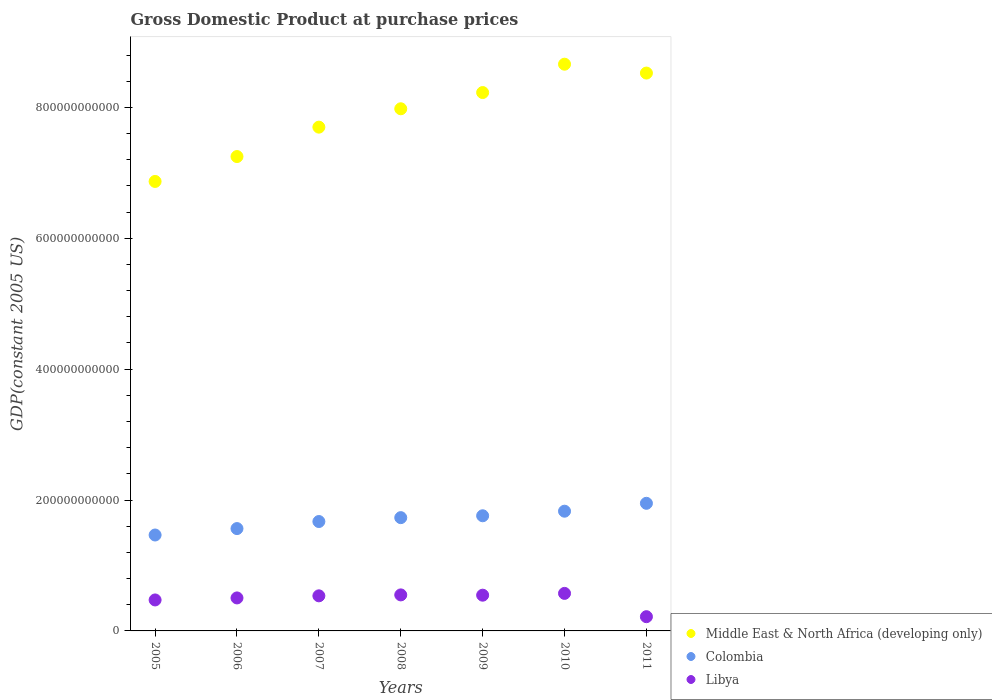How many different coloured dotlines are there?
Your response must be concise. 3. What is the GDP at purchase prices in Libya in 2009?
Offer a terse response. 5.46e+1. Across all years, what is the maximum GDP at purchase prices in Libya?
Give a very brief answer. 5.74e+1. Across all years, what is the minimum GDP at purchase prices in Colombia?
Provide a short and direct response. 1.47e+11. In which year was the GDP at purchase prices in Colombia maximum?
Give a very brief answer. 2011. In which year was the GDP at purchase prices in Libya minimum?
Make the answer very short. 2011. What is the total GDP at purchase prices in Libya in the graph?
Provide a succinct answer. 3.40e+11. What is the difference between the GDP at purchase prices in Libya in 2008 and that in 2011?
Your response must be concise. 3.33e+1. What is the difference between the GDP at purchase prices in Middle East & North Africa (developing only) in 2010 and the GDP at purchase prices in Colombia in 2009?
Your answer should be compact. 6.90e+11. What is the average GDP at purchase prices in Colombia per year?
Offer a terse response. 1.71e+11. In the year 2011, what is the difference between the GDP at purchase prices in Colombia and GDP at purchase prices in Libya?
Make the answer very short. 1.73e+11. In how many years, is the GDP at purchase prices in Middle East & North Africa (developing only) greater than 280000000000 US$?
Offer a terse response. 7. What is the ratio of the GDP at purchase prices in Middle East & North Africa (developing only) in 2005 to that in 2006?
Provide a succinct answer. 0.95. Is the GDP at purchase prices in Libya in 2005 less than that in 2009?
Keep it short and to the point. Yes. What is the difference between the highest and the second highest GDP at purchase prices in Libya?
Your response must be concise. 2.31e+09. What is the difference between the highest and the lowest GDP at purchase prices in Libya?
Offer a terse response. 3.56e+1. In how many years, is the GDP at purchase prices in Colombia greater than the average GDP at purchase prices in Colombia taken over all years?
Provide a short and direct response. 4. Is it the case that in every year, the sum of the GDP at purchase prices in Colombia and GDP at purchase prices in Middle East & North Africa (developing only)  is greater than the GDP at purchase prices in Libya?
Your response must be concise. Yes. How many dotlines are there?
Make the answer very short. 3. How many years are there in the graph?
Make the answer very short. 7. What is the difference between two consecutive major ticks on the Y-axis?
Your response must be concise. 2.00e+11. Are the values on the major ticks of Y-axis written in scientific E-notation?
Keep it short and to the point. No. How many legend labels are there?
Your answer should be very brief. 3. How are the legend labels stacked?
Keep it short and to the point. Vertical. What is the title of the graph?
Make the answer very short. Gross Domestic Product at purchase prices. What is the label or title of the Y-axis?
Provide a succinct answer. GDP(constant 2005 US). What is the GDP(constant 2005 US) in Middle East & North Africa (developing only) in 2005?
Ensure brevity in your answer.  6.87e+11. What is the GDP(constant 2005 US) of Colombia in 2005?
Your answer should be compact. 1.47e+11. What is the GDP(constant 2005 US) in Libya in 2005?
Your answer should be compact. 4.73e+1. What is the GDP(constant 2005 US) of Middle East & North Africa (developing only) in 2006?
Your answer should be compact. 7.25e+11. What is the GDP(constant 2005 US) of Colombia in 2006?
Ensure brevity in your answer.  1.56e+11. What is the GDP(constant 2005 US) in Libya in 2006?
Provide a short and direct response. 5.04e+1. What is the GDP(constant 2005 US) of Middle East & North Africa (developing only) in 2007?
Provide a succinct answer. 7.70e+11. What is the GDP(constant 2005 US) of Colombia in 2007?
Provide a short and direct response. 1.67e+11. What is the GDP(constant 2005 US) of Libya in 2007?
Ensure brevity in your answer.  5.36e+1. What is the GDP(constant 2005 US) of Middle East & North Africa (developing only) in 2008?
Your answer should be compact. 7.98e+11. What is the GDP(constant 2005 US) of Colombia in 2008?
Your response must be concise. 1.73e+11. What is the GDP(constant 2005 US) of Libya in 2008?
Offer a very short reply. 5.50e+1. What is the GDP(constant 2005 US) in Middle East & North Africa (developing only) in 2009?
Ensure brevity in your answer.  8.23e+11. What is the GDP(constant 2005 US) of Colombia in 2009?
Give a very brief answer. 1.76e+11. What is the GDP(constant 2005 US) in Libya in 2009?
Provide a succinct answer. 5.46e+1. What is the GDP(constant 2005 US) in Middle East & North Africa (developing only) in 2010?
Make the answer very short. 8.66e+11. What is the GDP(constant 2005 US) of Colombia in 2010?
Offer a very short reply. 1.83e+11. What is the GDP(constant 2005 US) of Libya in 2010?
Your answer should be compact. 5.74e+1. What is the GDP(constant 2005 US) of Middle East & North Africa (developing only) in 2011?
Your answer should be very brief. 8.52e+11. What is the GDP(constant 2005 US) in Colombia in 2011?
Your response must be concise. 1.95e+11. What is the GDP(constant 2005 US) in Libya in 2011?
Ensure brevity in your answer.  2.17e+1. Across all years, what is the maximum GDP(constant 2005 US) of Middle East & North Africa (developing only)?
Your answer should be very brief. 8.66e+11. Across all years, what is the maximum GDP(constant 2005 US) of Colombia?
Make the answer very short. 1.95e+11. Across all years, what is the maximum GDP(constant 2005 US) of Libya?
Ensure brevity in your answer.  5.74e+1. Across all years, what is the minimum GDP(constant 2005 US) in Middle East & North Africa (developing only)?
Keep it short and to the point. 6.87e+11. Across all years, what is the minimum GDP(constant 2005 US) of Colombia?
Your answer should be very brief. 1.47e+11. Across all years, what is the minimum GDP(constant 2005 US) in Libya?
Your answer should be very brief. 2.17e+1. What is the total GDP(constant 2005 US) of Middle East & North Africa (developing only) in the graph?
Your response must be concise. 5.52e+12. What is the total GDP(constant 2005 US) of Colombia in the graph?
Your answer should be compact. 1.20e+12. What is the total GDP(constant 2005 US) of Libya in the graph?
Provide a succinct answer. 3.40e+11. What is the difference between the GDP(constant 2005 US) in Middle East & North Africa (developing only) in 2005 and that in 2006?
Provide a succinct answer. -3.80e+1. What is the difference between the GDP(constant 2005 US) of Colombia in 2005 and that in 2006?
Give a very brief answer. -9.82e+09. What is the difference between the GDP(constant 2005 US) of Libya in 2005 and that in 2006?
Your answer should be very brief. -3.08e+09. What is the difference between the GDP(constant 2005 US) of Middle East & North Africa (developing only) in 2005 and that in 2007?
Your response must be concise. -8.30e+1. What is the difference between the GDP(constant 2005 US) in Colombia in 2005 and that in 2007?
Provide a short and direct response. -2.06e+1. What is the difference between the GDP(constant 2005 US) of Libya in 2005 and that in 2007?
Keep it short and to the point. -6.28e+09. What is the difference between the GDP(constant 2005 US) in Middle East & North Africa (developing only) in 2005 and that in 2008?
Provide a short and direct response. -1.11e+11. What is the difference between the GDP(constant 2005 US) of Colombia in 2005 and that in 2008?
Ensure brevity in your answer.  -2.65e+1. What is the difference between the GDP(constant 2005 US) in Libya in 2005 and that in 2008?
Your response must be concise. -7.71e+09. What is the difference between the GDP(constant 2005 US) of Middle East & North Africa (developing only) in 2005 and that in 2009?
Offer a terse response. -1.36e+11. What is the difference between the GDP(constant 2005 US) in Colombia in 2005 and that in 2009?
Your response must be concise. -2.94e+1. What is the difference between the GDP(constant 2005 US) of Libya in 2005 and that in 2009?
Your answer should be compact. -7.27e+09. What is the difference between the GDP(constant 2005 US) of Middle East & North Africa (developing only) in 2005 and that in 2010?
Provide a short and direct response. -1.79e+11. What is the difference between the GDP(constant 2005 US) in Colombia in 2005 and that in 2010?
Make the answer very short. -3.64e+1. What is the difference between the GDP(constant 2005 US) in Libya in 2005 and that in 2010?
Give a very brief answer. -1.00e+1. What is the difference between the GDP(constant 2005 US) in Middle East & North Africa (developing only) in 2005 and that in 2011?
Your response must be concise. -1.66e+11. What is the difference between the GDP(constant 2005 US) of Colombia in 2005 and that in 2011?
Ensure brevity in your answer.  -4.84e+1. What is the difference between the GDP(constant 2005 US) in Libya in 2005 and that in 2011?
Give a very brief answer. 2.56e+1. What is the difference between the GDP(constant 2005 US) in Middle East & North Africa (developing only) in 2006 and that in 2007?
Your answer should be very brief. -4.49e+1. What is the difference between the GDP(constant 2005 US) in Colombia in 2006 and that in 2007?
Your response must be concise. -1.08e+1. What is the difference between the GDP(constant 2005 US) in Libya in 2006 and that in 2007?
Provide a succinct answer. -3.20e+09. What is the difference between the GDP(constant 2005 US) in Middle East & North Africa (developing only) in 2006 and that in 2008?
Offer a very short reply. -7.30e+1. What is the difference between the GDP(constant 2005 US) in Colombia in 2006 and that in 2008?
Offer a terse response. -1.67e+1. What is the difference between the GDP(constant 2005 US) of Libya in 2006 and that in 2008?
Give a very brief answer. -4.63e+09. What is the difference between the GDP(constant 2005 US) in Middle East & North Africa (developing only) in 2006 and that in 2009?
Ensure brevity in your answer.  -9.78e+1. What is the difference between the GDP(constant 2005 US) in Colombia in 2006 and that in 2009?
Offer a very short reply. -1.96e+1. What is the difference between the GDP(constant 2005 US) in Libya in 2006 and that in 2009?
Offer a very short reply. -4.20e+09. What is the difference between the GDP(constant 2005 US) of Middle East & North Africa (developing only) in 2006 and that in 2010?
Give a very brief answer. -1.41e+11. What is the difference between the GDP(constant 2005 US) of Colombia in 2006 and that in 2010?
Your answer should be compact. -2.66e+1. What is the difference between the GDP(constant 2005 US) in Libya in 2006 and that in 2010?
Make the answer very short. -6.94e+09. What is the difference between the GDP(constant 2005 US) in Middle East & North Africa (developing only) in 2006 and that in 2011?
Provide a succinct answer. -1.28e+11. What is the difference between the GDP(constant 2005 US) of Colombia in 2006 and that in 2011?
Provide a short and direct response. -3.86e+1. What is the difference between the GDP(constant 2005 US) in Libya in 2006 and that in 2011?
Provide a succinct answer. 2.87e+1. What is the difference between the GDP(constant 2005 US) in Middle East & North Africa (developing only) in 2007 and that in 2008?
Give a very brief answer. -2.81e+1. What is the difference between the GDP(constant 2005 US) of Colombia in 2007 and that in 2008?
Offer a very short reply. -5.93e+09. What is the difference between the GDP(constant 2005 US) of Libya in 2007 and that in 2008?
Your answer should be compact. -1.43e+09. What is the difference between the GDP(constant 2005 US) in Middle East & North Africa (developing only) in 2007 and that in 2009?
Make the answer very short. -5.29e+1. What is the difference between the GDP(constant 2005 US) in Colombia in 2007 and that in 2009?
Offer a terse response. -8.79e+09. What is the difference between the GDP(constant 2005 US) in Libya in 2007 and that in 2009?
Provide a short and direct response. -9.95e+08. What is the difference between the GDP(constant 2005 US) in Middle East & North Africa (developing only) in 2007 and that in 2010?
Your answer should be very brief. -9.62e+1. What is the difference between the GDP(constant 2005 US) of Colombia in 2007 and that in 2010?
Give a very brief answer. -1.58e+1. What is the difference between the GDP(constant 2005 US) of Libya in 2007 and that in 2010?
Make the answer very short. -3.74e+09. What is the difference between the GDP(constant 2005 US) of Middle East & North Africa (developing only) in 2007 and that in 2011?
Ensure brevity in your answer.  -8.26e+1. What is the difference between the GDP(constant 2005 US) of Colombia in 2007 and that in 2011?
Make the answer very short. -2.78e+1. What is the difference between the GDP(constant 2005 US) of Libya in 2007 and that in 2011?
Ensure brevity in your answer.  3.19e+1. What is the difference between the GDP(constant 2005 US) in Middle East & North Africa (developing only) in 2008 and that in 2009?
Your answer should be very brief. -2.48e+1. What is the difference between the GDP(constant 2005 US) in Colombia in 2008 and that in 2009?
Offer a very short reply. -2.86e+09. What is the difference between the GDP(constant 2005 US) of Libya in 2008 and that in 2009?
Your response must be concise. 4.35e+08. What is the difference between the GDP(constant 2005 US) of Middle East & North Africa (developing only) in 2008 and that in 2010?
Provide a short and direct response. -6.81e+1. What is the difference between the GDP(constant 2005 US) of Colombia in 2008 and that in 2010?
Your answer should be very brief. -9.85e+09. What is the difference between the GDP(constant 2005 US) in Libya in 2008 and that in 2010?
Give a very brief answer. -2.31e+09. What is the difference between the GDP(constant 2005 US) of Middle East & North Africa (developing only) in 2008 and that in 2011?
Ensure brevity in your answer.  -5.46e+1. What is the difference between the GDP(constant 2005 US) of Colombia in 2008 and that in 2011?
Your answer should be compact. -2.19e+1. What is the difference between the GDP(constant 2005 US) in Libya in 2008 and that in 2011?
Offer a very short reply. 3.33e+1. What is the difference between the GDP(constant 2005 US) in Middle East & North Africa (developing only) in 2009 and that in 2010?
Offer a terse response. -4.33e+1. What is the difference between the GDP(constant 2005 US) of Colombia in 2009 and that in 2010?
Provide a short and direct response. -6.99e+09. What is the difference between the GDP(constant 2005 US) in Libya in 2009 and that in 2010?
Your answer should be compact. -2.74e+09. What is the difference between the GDP(constant 2005 US) in Middle East & North Africa (developing only) in 2009 and that in 2011?
Ensure brevity in your answer.  -2.98e+1. What is the difference between the GDP(constant 2005 US) of Colombia in 2009 and that in 2011?
Make the answer very short. -1.90e+1. What is the difference between the GDP(constant 2005 US) in Libya in 2009 and that in 2011?
Your answer should be compact. 3.29e+1. What is the difference between the GDP(constant 2005 US) of Middle East & North Africa (developing only) in 2010 and that in 2011?
Ensure brevity in your answer.  1.36e+1. What is the difference between the GDP(constant 2005 US) in Colombia in 2010 and that in 2011?
Your response must be concise. -1.21e+1. What is the difference between the GDP(constant 2005 US) in Libya in 2010 and that in 2011?
Offer a terse response. 3.56e+1. What is the difference between the GDP(constant 2005 US) in Middle East & North Africa (developing only) in 2005 and the GDP(constant 2005 US) in Colombia in 2006?
Keep it short and to the point. 5.30e+11. What is the difference between the GDP(constant 2005 US) in Middle East & North Africa (developing only) in 2005 and the GDP(constant 2005 US) in Libya in 2006?
Ensure brevity in your answer.  6.36e+11. What is the difference between the GDP(constant 2005 US) of Colombia in 2005 and the GDP(constant 2005 US) of Libya in 2006?
Your answer should be compact. 9.62e+1. What is the difference between the GDP(constant 2005 US) of Middle East & North Africa (developing only) in 2005 and the GDP(constant 2005 US) of Colombia in 2007?
Make the answer very short. 5.20e+11. What is the difference between the GDP(constant 2005 US) in Middle East & North Africa (developing only) in 2005 and the GDP(constant 2005 US) in Libya in 2007?
Provide a short and direct response. 6.33e+11. What is the difference between the GDP(constant 2005 US) of Colombia in 2005 and the GDP(constant 2005 US) of Libya in 2007?
Your answer should be compact. 9.30e+1. What is the difference between the GDP(constant 2005 US) in Middle East & North Africa (developing only) in 2005 and the GDP(constant 2005 US) in Colombia in 2008?
Give a very brief answer. 5.14e+11. What is the difference between the GDP(constant 2005 US) in Middle East & North Africa (developing only) in 2005 and the GDP(constant 2005 US) in Libya in 2008?
Give a very brief answer. 6.32e+11. What is the difference between the GDP(constant 2005 US) in Colombia in 2005 and the GDP(constant 2005 US) in Libya in 2008?
Offer a very short reply. 9.15e+1. What is the difference between the GDP(constant 2005 US) of Middle East & North Africa (developing only) in 2005 and the GDP(constant 2005 US) of Colombia in 2009?
Your answer should be compact. 5.11e+11. What is the difference between the GDP(constant 2005 US) of Middle East & North Africa (developing only) in 2005 and the GDP(constant 2005 US) of Libya in 2009?
Provide a succinct answer. 6.32e+11. What is the difference between the GDP(constant 2005 US) in Colombia in 2005 and the GDP(constant 2005 US) in Libya in 2009?
Your answer should be very brief. 9.20e+1. What is the difference between the GDP(constant 2005 US) in Middle East & North Africa (developing only) in 2005 and the GDP(constant 2005 US) in Colombia in 2010?
Give a very brief answer. 5.04e+11. What is the difference between the GDP(constant 2005 US) of Middle East & North Africa (developing only) in 2005 and the GDP(constant 2005 US) of Libya in 2010?
Offer a very short reply. 6.29e+11. What is the difference between the GDP(constant 2005 US) of Colombia in 2005 and the GDP(constant 2005 US) of Libya in 2010?
Keep it short and to the point. 8.92e+1. What is the difference between the GDP(constant 2005 US) of Middle East & North Africa (developing only) in 2005 and the GDP(constant 2005 US) of Colombia in 2011?
Keep it short and to the point. 4.92e+11. What is the difference between the GDP(constant 2005 US) in Middle East & North Africa (developing only) in 2005 and the GDP(constant 2005 US) in Libya in 2011?
Your answer should be very brief. 6.65e+11. What is the difference between the GDP(constant 2005 US) in Colombia in 2005 and the GDP(constant 2005 US) in Libya in 2011?
Your response must be concise. 1.25e+11. What is the difference between the GDP(constant 2005 US) in Middle East & North Africa (developing only) in 2006 and the GDP(constant 2005 US) in Colombia in 2007?
Keep it short and to the point. 5.58e+11. What is the difference between the GDP(constant 2005 US) of Middle East & North Africa (developing only) in 2006 and the GDP(constant 2005 US) of Libya in 2007?
Keep it short and to the point. 6.71e+11. What is the difference between the GDP(constant 2005 US) in Colombia in 2006 and the GDP(constant 2005 US) in Libya in 2007?
Keep it short and to the point. 1.03e+11. What is the difference between the GDP(constant 2005 US) of Middle East & North Africa (developing only) in 2006 and the GDP(constant 2005 US) of Colombia in 2008?
Your response must be concise. 5.52e+11. What is the difference between the GDP(constant 2005 US) in Middle East & North Africa (developing only) in 2006 and the GDP(constant 2005 US) in Libya in 2008?
Offer a very short reply. 6.70e+11. What is the difference between the GDP(constant 2005 US) of Colombia in 2006 and the GDP(constant 2005 US) of Libya in 2008?
Your answer should be compact. 1.01e+11. What is the difference between the GDP(constant 2005 US) of Middle East & North Africa (developing only) in 2006 and the GDP(constant 2005 US) of Colombia in 2009?
Offer a terse response. 5.49e+11. What is the difference between the GDP(constant 2005 US) of Middle East & North Africa (developing only) in 2006 and the GDP(constant 2005 US) of Libya in 2009?
Your response must be concise. 6.70e+11. What is the difference between the GDP(constant 2005 US) in Colombia in 2006 and the GDP(constant 2005 US) in Libya in 2009?
Keep it short and to the point. 1.02e+11. What is the difference between the GDP(constant 2005 US) of Middle East & North Africa (developing only) in 2006 and the GDP(constant 2005 US) of Colombia in 2010?
Keep it short and to the point. 5.42e+11. What is the difference between the GDP(constant 2005 US) of Middle East & North Africa (developing only) in 2006 and the GDP(constant 2005 US) of Libya in 2010?
Your answer should be very brief. 6.68e+11. What is the difference between the GDP(constant 2005 US) of Colombia in 2006 and the GDP(constant 2005 US) of Libya in 2010?
Provide a short and direct response. 9.90e+1. What is the difference between the GDP(constant 2005 US) of Middle East & North Africa (developing only) in 2006 and the GDP(constant 2005 US) of Colombia in 2011?
Your answer should be compact. 5.30e+11. What is the difference between the GDP(constant 2005 US) of Middle East & North Africa (developing only) in 2006 and the GDP(constant 2005 US) of Libya in 2011?
Give a very brief answer. 7.03e+11. What is the difference between the GDP(constant 2005 US) of Colombia in 2006 and the GDP(constant 2005 US) of Libya in 2011?
Make the answer very short. 1.35e+11. What is the difference between the GDP(constant 2005 US) of Middle East & North Africa (developing only) in 2007 and the GDP(constant 2005 US) of Colombia in 2008?
Ensure brevity in your answer.  5.97e+11. What is the difference between the GDP(constant 2005 US) in Middle East & North Africa (developing only) in 2007 and the GDP(constant 2005 US) in Libya in 2008?
Ensure brevity in your answer.  7.15e+11. What is the difference between the GDP(constant 2005 US) of Colombia in 2007 and the GDP(constant 2005 US) of Libya in 2008?
Your response must be concise. 1.12e+11. What is the difference between the GDP(constant 2005 US) of Middle East & North Africa (developing only) in 2007 and the GDP(constant 2005 US) of Colombia in 2009?
Give a very brief answer. 5.94e+11. What is the difference between the GDP(constant 2005 US) in Middle East & North Africa (developing only) in 2007 and the GDP(constant 2005 US) in Libya in 2009?
Your answer should be very brief. 7.15e+11. What is the difference between the GDP(constant 2005 US) of Colombia in 2007 and the GDP(constant 2005 US) of Libya in 2009?
Your answer should be compact. 1.13e+11. What is the difference between the GDP(constant 2005 US) in Middle East & North Africa (developing only) in 2007 and the GDP(constant 2005 US) in Colombia in 2010?
Your answer should be very brief. 5.87e+11. What is the difference between the GDP(constant 2005 US) in Middle East & North Africa (developing only) in 2007 and the GDP(constant 2005 US) in Libya in 2010?
Provide a short and direct response. 7.12e+11. What is the difference between the GDP(constant 2005 US) in Colombia in 2007 and the GDP(constant 2005 US) in Libya in 2010?
Make the answer very short. 1.10e+11. What is the difference between the GDP(constant 2005 US) of Middle East & North Africa (developing only) in 2007 and the GDP(constant 2005 US) of Colombia in 2011?
Offer a very short reply. 5.75e+11. What is the difference between the GDP(constant 2005 US) of Middle East & North Africa (developing only) in 2007 and the GDP(constant 2005 US) of Libya in 2011?
Your answer should be very brief. 7.48e+11. What is the difference between the GDP(constant 2005 US) of Colombia in 2007 and the GDP(constant 2005 US) of Libya in 2011?
Keep it short and to the point. 1.45e+11. What is the difference between the GDP(constant 2005 US) of Middle East & North Africa (developing only) in 2008 and the GDP(constant 2005 US) of Colombia in 2009?
Your answer should be very brief. 6.22e+11. What is the difference between the GDP(constant 2005 US) of Middle East & North Africa (developing only) in 2008 and the GDP(constant 2005 US) of Libya in 2009?
Provide a succinct answer. 7.43e+11. What is the difference between the GDP(constant 2005 US) in Colombia in 2008 and the GDP(constant 2005 US) in Libya in 2009?
Keep it short and to the point. 1.18e+11. What is the difference between the GDP(constant 2005 US) in Middle East & North Africa (developing only) in 2008 and the GDP(constant 2005 US) in Colombia in 2010?
Make the answer very short. 6.15e+11. What is the difference between the GDP(constant 2005 US) in Middle East & North Africa (developing only) in 2008 and the GDP(constant 2005 US) in Libya in 2010?
Keep it short and to the point. 7.41e+11. What is the difference between the GDP(constant 2005 US) in Colombia in 2008 and the GDP(constant 2005 US) in Libya in 2010?
Ensure brevity in your answer.  1.16e+11. What is the difference between the GDP(constant 2005 US) in Middle East & North Africa (developing only) in 2008 and the GDP(constant 2005 US) in Colombia in 2011?
Ensure brevity in your answer.  6.03e+11. What is the difference between the GDP(constant 2005 US) in Middle East & North Africa (developing only) in 2008 and the GDP(constant 2005 US) in Libya in 2011?
Make the answer very short. 7.76e+11. What is the difference between the GDP(constant 2005 US) in Colombia in 2008 and the GDP(constant 2005 US) in Libya in 2011?
Offer a terse response. 1.51e+11. What is the difference between the GDP(constant 2005 US) in Middle East & North Africa (developing only) in 2009 and the GDP(constant 2005 US) in Colombia in 2010?
Make the answer very short. 6.40e+11. What is the difference between the GDP(constant 2005 US) of Middle East & North Africa (developing only) in 2009 and the GDP(constant 2005 US) of Libya in 2010?
Make the answer very short. 7.65e+11. What is the difference between the GDP(constant 2005 US) in Colombia in 2009 and the GDP(constant 2005 US) in Libya in 2010?
Your answer should be very brief. 1.19e+11. What is the difference between the GDP(constant 2005 US) of Middle East & North Africa (developing only) in 2009 and the GDP(constant 2005 US) of Colombia in 2011?
Your answer should be very brief. 6.28e+11. What is the difference between the GDP(constant 2005 US) in Middle East & North Africa (developing only) in 2009 and the GDP(constant 2005 US) in Libya in 2011?
Your answer should be very brief. 8.01e+11. What is the difference between the GDP(constant 2005 US) of Colombia in 2009 and the GDP(constant 2005 US) of Libya in 2011?
Provide a short and direct response. 1.54e+11. What is the difference between the GDP(constant 2005 US) in Middle East & North Africa (developing only) in 2010 and the GDP(constant 2005 US) in Colombia in 2011?
Provide a succinct answer. 6.71e+11. What is the difference between the GDP(constant 2005 US) of Middle East & North Africa (developing only) in 2010 and the GDP(constant 2005 US) of Libya in 2011?
Provide a short and direct response. 8.44e+11. What is the difference between the GDP(constant 2005 US) of Colombia in 2010 and the GDP(constant 2005 US) of Libya in 2011?
Keep it short and to the point. 1.61e+11. What is the average GDP(constant 2005 US) in Middle East & North Africa (developing only) per year?
Provide a succinct answer. 7.89e+11. What is the average GDP(constant 2005 US) in Colombia per year?
Offer a very short reply. 1.71e+11. What is the average GDP(constant 2005 US) of Libya per year?
Offer a terse response. 4.86e+1. In the year 2005, what is the difference between the GDP(constant 2005 US) of Middle East & North Africa (developing only) and GDP(constant 2005 US) of Colombia?
Your answer should be very brief. 5.40e+11. In the year 2005, what is the difference between the GDP(constant 2005 US) in Middle East & North Africa (developing only) and GDP(constant 2005 US) in Libya?
Keep it short and to the point. 6.40e+11. In the year 2005, what is the difference between the GDP(constant 2005 US) in Colombia and GDP(constant 2005 US) in Libya?
Make the answer very short. 9.92e+1. In the year 2006, what is the difference between the GDP(constant 2005 US) of Middle East & North Africa (developing only) and GDP(constant 2005 US) of Colombia?
Provide a succinct answer. 5.69e+11. In the year 2006, what is the difference between the GDP(constant 2005 US) in Middle East & North Africa (developing only) and GDP(constant 2005 US) in Libya?
Your response must be concise. 6.74e+11. In the year 2006, what is the difference between the GDP(constant 2005 US) in Colombia and GDP(constant 2005 US) in Libya?
Your answer should be very brief. 1.06e+11. In the year 2007, what is the difference between the GDP(constant 2005 US) in Middle East & North Africa (developing only) and GDP(constant 2005 US) in Colombia?
Provide a succinct answer. 6.03e+11. In the year 2007, what is the difference between the GDP(constant 2005 US) of Middle East & North Africa (developing only) and GDP(constant 2005 US) of Libya?
Provide a succinct answer. 7.16e+11. In the year 2007, what is the difference between the GDP(constant 2005 US) of Colombia and GDP(constant 2005 US) of Libya?
Offer a terse response. 1.14e+11. In the year 2008, what is the difference between the GDP(constant 2005 US) of Middle East & North Africa (developing only) and GDP(constant 2005 US) of Colombia?
Provide a short and direct response. 6.25e+11. In the year 2008, what is the difference between the GDP(constant 2005 US) in Middle East & North Africa (developing only) and GDP(constant 2005 US) in Libya?
Keep it short and to the point. 7.43e+11. In the year 2008, what is the difference between the GDP(constant 2005 US) in Colombia and GDP(constant 2005 US) in Libya?
Your answer should be compact. 1.18e+11. In the year 2009, what is the difference between the GDP(constant 2005 US) of Middle East & North Africa (developing only) and GDP(constant 2005 US) of Colombia?
Give a very brief answer. 6.47e+11. In the year 2009, what is the difference between the GDP(constant 2005 US) in Middle East & North Africa (developing only) and GDP(constant 2005 US) in Libya?
Your response must be concise. 7.68e+11. In the year 2009, what is the difference between the GDP(constant 2005 US) in Colombia and GDP(constant 2005 US) in Libya?
Offer a terse response. 1.21e+11. In the year 2010, what is the difference between the GDP(constant 2005 US) in Middle East & North Africa (developing only) and GDP(constant 2005 US) in Colombia?
Provide a succinct answer. 6.83e+11. In the year 2010, what is the difference between the GDP(constant 2005 US) of Middle East & North Africa (developing only) and GDP(constant 2005 US) of Libya?
Your answer should be very brief. 8.09e+11. In the year 2010, what is the difference between the GDP(constant 2005 US) in Colombia and GDP(constant 2005 US) in Libya?
Your response must be concise. 1.26e+11. In the year 2011, what is the difference between the GDP(constant 2005 US) in Middle East & North Africa (developing only) and GDP(constant 2005 US) in Colombia?
Ensure brevity in your answer.  6.57e+11. In the year 2011, what is the difference between the GDP(constant 2005 US) in Middle East & North Africa (developing only) and GDP(constant 2005 US) in Libya?
Offer a terse response. 8.31e+11. In the year 2011, what is the difference between the GDP(constant 2005 US) of Colombia and GDP(constant 2005 US) of Libya?
Ensure brevity in your answer.  1.73e+11. What is the ratio of the GDP(constant 2005 US) in Middle East & North Africa (developing only) in 2005 to that in 2006?
Make the answer very short. 0.95. What is the ratio of the GDP(constant 2005 US) of Colombia in 2005 to that in 2006?
Offer a very short reply. 0.94. What is the ratio of the GDP(constant 2005 US) of Libya in 2005 to that in 2006?
Provide a succinct answer. 0.94. What is the ratio of the GDP(constant 2005 US) in Middle East & North Africa (developing only) in 2005 to that in 2007?
Your answer should be compact. 0.89. What is the ratio of the GDP(constant 2005 US) in Colombia in 2005 to that in 2007?
Ensure brevity in your answer.  0.88. What is the ratio of the GDP(constant 2005 US) in Libya in 2005 to that in 2007?
Provide a short and direct response. 0.88. What is the ratio of the GDP(constant 2005 US) of Middle East & North Africa (developing only) in 2005 to that in 2008?
Keep it short and to the point. 0.86. What is the ratio of the GDP(constant 2005 US) of Colombia in 2005 to that in 2008?
Your response must be concise. 0.85. What is the ratio of the GDP(constant 2005 US) of Libya in 2005 to that in 2008?
Ensure brevity in your answer.  0.86. What is the ratio of the GDP(constant 2005 US) of Middle East & North Africa (developing only) in 2005 to that in 2009?
Keep it short and to the point. 0.83. What is the ratio of the GDP(constant 2005 US) of Colombia in 2005 to that in 2009?
Keep it short and to the point. 0.83. What is the ratio of the GDP(constant 2005 US) in Libya in 2005 to that in 2009?
Offer a terse response. 0.87. What is the ratio of the GDP(constant 2005 US) of Middle East & North Africa (developing only) in 2005 to that in 2010?
Ensure brevity in your answer.  0.79. What is the ratio of the GDP(constant 2005 US) of Colombia in 2005 to that in 2010?
Provide a succinct answer. 0.8. What is the ratio of the GDP(constant 2005 US) of Libya in 2005 to that in 2010?
Your response must be concise. 0.83. What is the ratio of the GDP(constant 2005 US) of Middle East & North Africa (developing only) in 2005 to that in 2011?
Offer a very short reply. 0.81. What is the ratio of the GDP(constant 2005 US) of Colombia in 2005 to that in 2011?
Your response must be concise. 0.75. What is the ratio of the GDP(constant 2005 US) of Libya in 2005 to that in 2011?
Offer a very short reply. 2.18. What is the ratio of the GDP(constant 2005 US) of Middle East & North Africa (developing only) in 2006 to that in 2007?
Your response must be concise. 0.94. What is the ratio of the GDP(constant 2005 US) in Colombia in 2006 to that in 2007?
Your answer should be very brief. 0.94. What is the ratio of the GDP(constant 2005 US) of Libya in 2006 to that in 2007?
Provide a short and direct response. 0.94. What is the ratio of the GDP(constant 2005 US) of Middle East & North Africa (developing only) in 2006 to that in 2008?
Keep it short and to the point. 0.91. What is the ratio of the GDP(constant 2005 US) of Colombia in 2006 to that in 2008?
Provide a short and direct response. 0.9. What is the ratio of the GDP(constant 2005 US) in Libya in 2006 to that in 2008?
Your answer should be very brief. 0.92. What is the ratio of the GDP(constant 2005 US) in Middle East & North Africa (developing only) in 2006 to that in 2009?
Provide a short and direct response. 0.88. What is the ratio of the GDP(constant 2005 US) in Colombia in 2006 to that in 2009?
Offer a terse response. 0.89. What is the ratio of the GDP(constant 2005 US) in Libya in 2006 to that in 2009?
Keep it short and to the point. 0.92. What is the ratio of the GDP(constant 2005 US) in Middle East & North Africa (developing only) in 2006 to that in 2010?
Offer a terse response. 0.84. What is the ratio of the GDP(constant 2005 US) in Colombia in 2006 to that in 2010?
Provide a succinct answer. 0.85. What is the ratio of the GDP(constant 2005 US) of Libya in 2006 to that in 2010?
Your answer should be very brief. 0.88. What is the ratio of the GDP(constant 2005 US) of Middle East & North Africa (developing only) in 2006 to that in 2011?
Offer a very short reply. 0.85. What is the ratio of the GDP(constant 2005 US) in Colombia in 2006 to that in 2011?
Provide a short and direct response. 0.8. What is the ratio of the GDP(constant 2005 US) of Libya in 2006 to that in 2011?
Provide a short and direct response. 2.32. What is the ratio of the GDP(constant 2005 US) of Middle East & North Africa (developing only) in 2007 to that in 2008?
Make the answer very short. 0.96. What is the ratio of the GDP(constant 2005 US) of Colombia in 2007 to that in 2008?
Your answer should be compact. 0.97. What is the ratio of the GDP(constant 2005 US) in Libya in 2007 to that in 2008?
Provide a short and direct response. 0.97. What is the ratio of the GDP(constant 2005 US) of Middle East & North Africa (developing only) in 2007 to that in 2009?
Provide a succinct answer. 0.94. What is the ratio of the GDP(constant 2005 US) in Colombia in 2007 to that in 2009?
Offer a terse response. 0.95. What is the ratio of the GDP(constant 2005 US) in Libya in 2007 to that in 2009?
Provide a succinct answer. 0.98. What is the ratio of the GDP(constant 2005 US) in Middle East & North Africa (developing only) in 2007 to that in 2010?
Ensure brevity in your answer.  0.89. What is the ratio of the GDP(constant 2005 US) in Colombia in 2007 to that in 2010?
Your answer should be compact. 0.91. What is the ratio of the GDP(constant 2005 US) of Libya in 2007 to that in 2010?
Provide a succinct answer. 0.93. What is the ratio of the GDP(constant 2005 US) of Middle East & North Africa (developing only) in 2007 to that in 2011?
Make the answer very short. 0.9. What is the ratio of the GDP(constant 2005 US) in Colombia in 2007 to that in 2011?
Keep it short and to the point. 0.86. What is the ratio of the GDP(constant 2005 US) of Libya in 2007 to that in 2011?
Offer a terse response. 2.46. What is the ratio of the GDP(constant 2005 US) of Middle East & North Africa (developing only) in 2008 to that in 2009?
Your answer should be very brief. 0.97. What is the ratio of the GDP(constant 2005 US) of Colombia in 2008 to that in 2009?
Your answer should be very brief. 0.98. What is the ratio of the GDP(constant 2005 US) of Middle East & North Africa (developing only) in 2008 to that in 2010?
Give a very brief answer. 0.92. What is the ratio of the GDP(constant 2005 US) in Colombia in 2008 to that in 2010?
Ensure brevity in your answer.  0.95. What is the ratio of the GDP(constant 2005 US) of Libya in 2008 to that in 2010?
Provide a short and direct response. 0.96. What is the ratio of the GDP(constant 2005 US) in Middle East & North Africa (developing only) in 2008 to that in 2011?
Your response must be concise. 0.94. What is the ratio of the GDP(constant 2005 US) of Colombia in 2008 to that in 2011?
Offer a very short reply. 0.89. What is the ratio of the GDP(constant 2005 US) of Libya in 2008 to that in 2011?
Make the answer very short. 2.53. What is the ratio of the GDP(constant 2005 US) of Middle East & North Africa (developing only) in 2009 to that in 2010?
Ensure brevity in your answer.  0.95. What is the ratio of the GDP(constant 2005 US) in Colombia in 2009 to that in 2010?
Keep it short and to the point. 0.96. What is the ratio of the GDP(constant 2005 US) of Libya in 2009 to that in 2010?
Your answer should be very brief. 0.95. What is the ratio of the GDP(constant 2005 US) of Middle East & North Africa (developing only) in 2009 to that in 2011?
Your response must be concise. 0.97. What is the ratio of the GDP(constant 2005 US) in Colombia in 2009 to that in 2011?
Make the answer very short. 0.9. What is the ratio of the GDP(constant 2005 US) of Libya in 2009 to that in 2011?
Offer a terse response. 2.51. What is the ratio of the GDP(constant 2005 US) of Middle East & North Africa (developing only) in 2010 to that in 2011?
Offer a very short reply. 1.02. What is the ratio of the GDP(constant 2005 US) of Colombia in 2010 to that in 2011?
Give a very brief answer. 0.94. What is the ratio of the GDP(constant 2005 US) in Libya in 2010 to that in 2011?
Provide a short and direct response. 2.64. What is the difference between the highest and the second highest GDP(constant 2005 US) of Middle East & North Africa (developing only)?
Make the answer very short. 1.36e+1. What is the difference between the highest and the second highest GDP(constant 2005 US) of Colombia?
Your response must be concise. 1.21e+1. What is the difference between the highest and the second highest GDP(constant 2005 US) in Libya?
Give a very brief answer. 2.31e+09. What is the difference between the highest and the lowest GDP(constant 2005 US) of Middle East & North Africa (developing only)?
Your answer should be compact. 1.79e+11. What is the difference between the highest and the lowest GDP(constant 2005 US) in Colombia?
Make the answer very short. 4.84e+1. What is the difference between the highest and the lowest GDP(constant 2005 US) of Libya?
Your answer should be very brief. 3.56e+1. 